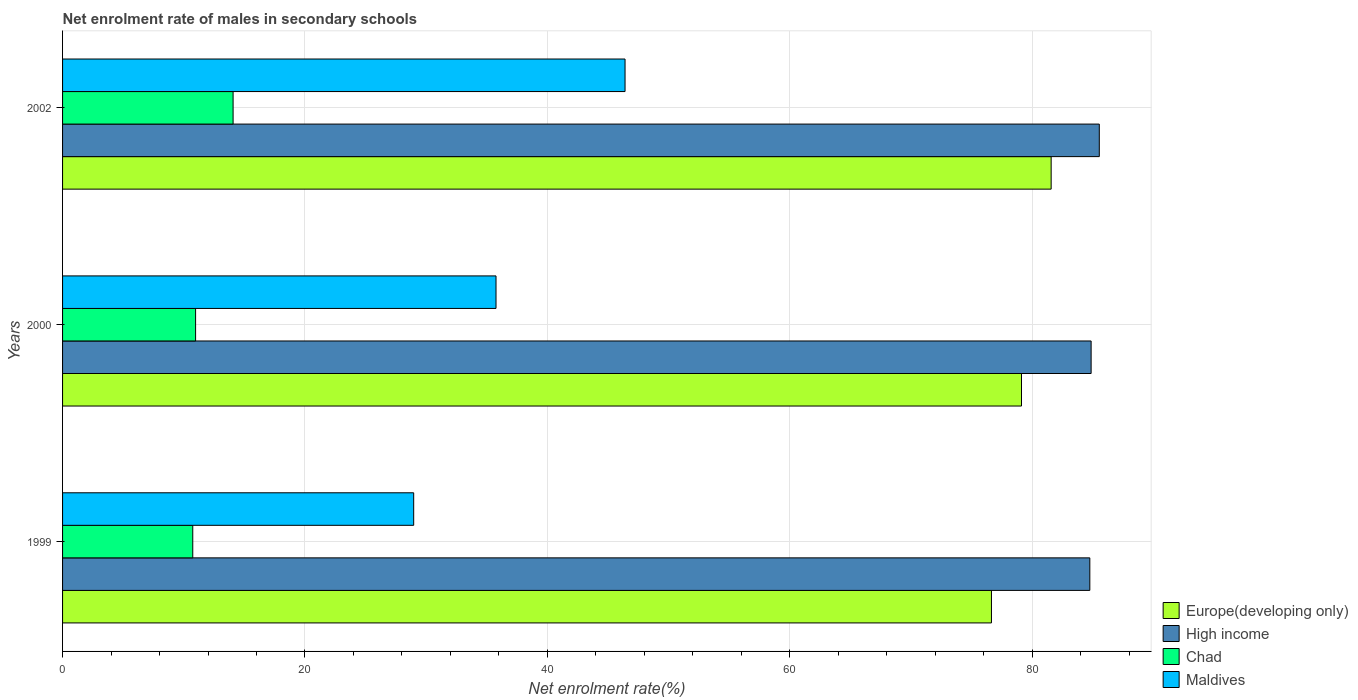How many different coloured bars are there?
Provide a succinct answer. 4. How many groups of bars are there?
Ensure brevity in your answer.  3. Are the number of bars per tick equal to the number of legend labels?
Ensure brevity in your answer.  Yes. Are the number of bars on each tick of the Y-axis equal?
Your response must be concise. Yes. How many bars are there on the 2nd tick from the bottom?
Your answer should be very brief. 4. What is the label of the 2nd group of bars from the top?
Your answer should be very brief. 2000. In how many cases, is the number of bars for a given year not equal to the number of legend labels?
Your answer should be compact. 0. What is the net enrolment rate of males in secondary schools in High income in 2002?
Your response must be concise. 85.54. Across all years, what is the maximum net enrolment rate of males in secondary schools in Europe(developing only)?
Provide a succinct answer. 81.56. Across all years, what is the minimum net enrolment rate of males in secondary schools in Chad?
Your answer should be compact. 10.74. What is the total net enrolment rate of males in secondary schools in Maldives in the graph?
Give a very brief answer. 111.14. What is the difference between the net enrolment rate of males in secondary schools in High income in 2000 and that in 2002?
Your answer should be compact. -0.67. What is the difference between the net enrolment rate of males in secondary schools in High income in 2000 and the net enrolment rate of males in secondary schools in Maldives in 1999?
Ensure brevity in your answer.  55.89. What is the average net enrolment rate of males in secondary schools in Maldives per year?
Make the answer very short. 37.05. In the year 1999, what is the difference between the net enrolment rate of males in secondary schools in High income and net enrolment rate of males in secondary schools in Europe(developing only)?
Give a very brief answer. 8.12. In how many years, is the net enrolment rate of males in secondary schools in Europe(developing only) greater than 28 %?
Keep it short and to the point. 3. What is the ratio of the net enrolment rate of males in secondary schools in High income in 1999 to that in 2000?
Your response must be concise. 1. Is the net enrolment rate of males in secondary schools in Chad in 2000 less than that in 2002?
Give a very brief answer. Yes. Is the difference between the net enrolment rate of males in secondary schools in High income in 1999 and 2000 greater than the difference between the net enrolment rate of males in secondary schools in Europe(developing only) in 1999 and 2000?
Provide a succinct answer. Yes. What is the difference between the highest and the second highest net enrolment rate of males in secondary schools in Chad?
Offer a very short reply. 3.09. What is the difference between the highest and the lowest net enrolment rate of males in secondary schools in Europe(developing only)?
Offer a terse response. 4.93. In how many years, is the net enrolment rate of males in secondary schools in Chad greater than the average net enrolment rate of males in secondary schools in Chad taken over all years?
Provide a short and direct response. 1. What does the 2nd bar from the top in 2002 represents?
Your response must be concise. Chad. What does the 3rd bar from the bottom in 1999 represents?
Your answer should be compact. Chad. Is it the case that in every year, the sum of the net enrolment rate of males in secondary schools in High income and net enrolment rate of males in secondary schools in Europe(developing only) is greater than the net enrolment rate of males in secondary schools in Maldives?
Offer a terse response. Yes. How many bars are there?
Your answer should be compact. 12. How many years are there in the graph?
Your answer should be compact. 3. What is the difference between two consecutive major ticks on the X-axis?
Offer a terse response. 20. Does the graph contain any zero values?
Keep it short and to the point. No. What is the title of the graph?
Offer a terse response. Net enrolment rate of males in secondary schools. What is the label or title of the X-axis?
Ensure brevity in your answer.  Net enrolment rate(%). What is the label or title of the Y-axis?
Give a very brief answer. Years. What is the Net enrolment rate(%) in Europe(developing only) in 1999?
Offer a terse response. 76.64. What is the Net enrolment rate(%) in High income in 1999?
Give a very brief answer. 84.75. What is the Net enrolment rate(%) of Chad in 1999?
Make the answer very short. 10.74. What is the Net enrolment rate(%) of Maldives in 1999?
Make the answer very short. 28.97. What is the Net enrolment rate(%) in Europe(developing only) in 2000?
Give a very brief answer. 79.12. What is the Net enrolment rate(%) in High income in 2000?
Make the answer very short. 84.86. What is the Net enrolment rate(%) of Chad in 2000?
Provide a short and direct response. 10.98. What is the Net enrolment rate(%) of Maldives in 2000?
Provide a short and direct response. 35.76. What is the Net enrolment rate(%) of Europe(developing only) in 2002?
Provide a short and direct response. 81.56. What is the Net enrolment rate(%) in High income in 2002?
Give a very brief answer. 85.54. What is the Net enrolment rate(%) of Chad in 2002?
Give a very brief answer. 14.07. What is the Net enrolment rate(%) of Maldives in 2002?
Your answer should be very brief. 46.41. Across all years, what is the maximum Net enrolment rate(%) of Europe(developing only)?
Make the answer very short. 81.56. Across all years, what is the maximum Net enrolment rate(%) in High income?
Provide a succinct answer. 85.54. Across all years, what is the maximum Net enrolment rate(%) of Chad?
Provide a succinct answer. 14.07. Across all years, what is the maximum Net enrolment rate(%) of Maldives?
Ensure brevity in your answer.  46.41. Across all years, what is the minimum Net enrolment rate(%) of Europe(developing only)?
Ensure brevity in your answer.  76.64. Across all years, what is the minimum Net enrolment rate(%) in High income?
Provide a succinct answer. 84.75. Across all years, what is the minimum Net enrolment rate(%) in Chad?
Provide a succinct answer. 10.74. Across all years, what is the minimum Net enrolment rate(%) in Maldives?
Your answer should be compact. 28.97. What is the total Net enrolment rate(%) in Europe(developing only) in the graph?
Provide a succinct answer. 237.32. What is the total Net enrolment rate(%) of High income in the graph?
Provide a succinct answer. 255.15. What is the total Net enrolment rate(%) in Chad in the graph?
Ensure brevity in your answer.  35.79. What is the total Net enrolment rate(%) in Maldives in the graph?
Offer a terse response. 111.14. What is the difference between the Net enrolment rate(%) in Europe(developing only) in 1999 and that in 2000?
Keep it short and to the point. -2.48. What is the difference between the Net enrolment rate(%) in High income in 1999 and that in 2000?
Keep it short and to the point. -0.11. What is the difference between the Net enrolment rate(%) of Chad in 1999 and that in 2000?
Provide a short and direct response. -0.23. What is the difference between the Net enrolment rate(%) in Maldives in 1999 and that in 2000?
Your answer should be very brief. -6.79. What is the difference between the Net enrolment rate(%) of Europe(developing only) in 1999 and that in 2002?
Give a very brief answer. -4.93. What is the difference between the Net enrolment rate(%) in High income in 1999 and that in 2002?
Offer a very short reply. -0.78. What is the difference between the Net enrolment rate(%) of Chad in 1999 and that in 2002?
Ensure brevity in your answer.  -3.33. What is the difference between the Net enrolment rate(%) of Maldives in 1999 and that in 2002?
Provide a succinct answer. -17.44. What is the difference between the Net enrolment rate(%) of Europe(developing only) in 2000 and that in 2002?
Your response must be concise. -2.45. What is the difference between the Net enrolment rate(%) in High income in 2000 and that in 2002?
Your answer should be very brief. -0.67. What is the difference between the Net enrolment rate(%) of Chad in 2000 and that in 2002?
Your response must be concise. -3.09. What is the difference between the Net enrolment rate(%) in Maldives in 2000 and that in 2002?
Offer a terse response. -10.65. What is the difference between the Net enrolment rate(%) in Europe(developing only) in 1999 and the Net enrolment rate(%) in High income in 2000?
Ensure brevity in your answer.  -8.22. What is the difference between the Net enrolment rate(%) of Europe(developing only) in 1999 and the Net enrolment rate(%) of Chad in 2000?
Make the answer very short. 65.66. What is the difference between the Net enrolment rate(%) in Europe(developing only) in 1999 and the Net enrolment rate(%) in Maldives in 2000?
Your answer should be very brief. 40.88. What is the difference between the Net enrolment rate(%) in High income in 1999 and the Net enrolment rate(%) in Chad in 2000?
Provide a succinct answer. 73.78. What is the difference between the Net enrolment rate(%) in High income in 1999 and the Net enrolment rate(%) in Maldives in 2000?
Make the answer very short. 48.99. What is the difference between the Net enrolment rate(%) of Chad in 1999 and the Net enrolment rate(%) of Maldives in 2000?
Give a very brief answer. -25.02. What is the difference between the Net enrolment rate(%) of Europe(developing only) in 1999 and the Net enrolment rate(%) of High income in 2002?
Offer a very short reply. -8.9. What is the difference between the Net enrolment rate(%) in Europe(developing only) in 1999 and the Net enrolment rate(%) in Chad in 2002?
Provide a succinct answer. 62.57. What is the difference between the Net enrolment rate(%) in Europe(developing only) in 1999 and the Net enrolment rate(%) in Maldives in 2002?
Give a very brief answer. 30.23. What is the difference between the Net enrolment rate(%) of High income in 1999 and the Net enrolment rate(%) of Chad in 2002?
Offer a very short reply. 70.69. What is the difference between the Net enrolment rate(%) in High income in 1999 and the Net enrolment rate(%) in Maldives in 2002?
Your answer should be very brief. 38.35. What is the difference between the Net enrolment rate(%) in Chad in 1999 and the Net enrolment rate(%) in Maldives in 2002?
Your answer should be very brief. -35.67. What is the difference between the Net enrolment rate(%) of Europe(developing only) in 2000 and the Net enrolment rate(%) of High income in 2002?
Make the answer very short. -6.42. What is the difference between the Net enrolment rate(%) in Europe(developing only) in 2000 and the Net enrolment rate(%) in Chad in 2002?
Ensure brevity in your answer.  65.05. What is the difference between the Net enrolment rate(%) of Europe(developing only) in 2000 and the Net enrolment rate(%) of Maldives in 2002?
Make the answer very short. 32.71. What is the difference between the Net enrolment rate(%) of High income in 2000 and the Net enrolment rate(%) of Chad in 2002?
Offer a very short reply. 70.79. What is the difference between the Net enrolment rate(%) in High income in 2000 and the Net enrolment rate(%) in Maldives in 2002?
Keep it short and to the point. 38.45. What is the difference between the Net enrolment rate(%) of Chad in 2000 and the Net enrolment rate(%) of Maldives in 2002?
Your answer should be very brief. -35.43. What is the average Net enrolment rate(%) of Europe(developing only) per year?
Keep it short and to the point. 79.11. What is the average Net enrolment rate(%) in High income per year?
Your answer should be very brief. 85.05. What is the average Net enrolment rate(%) in Chad per year?
Ensure brevity in your answer.  11.93. What is the average Net enrolment rate(%) of Maldives per year?
Your response must be concise. 37.05. In the year 1999, what is the difference between the Net enrolment rate(%) in Europe(developing only) and Net enrolment rate(%) in High income?
Offer a terse response. -8.12. In the year 1999, what is the difference between the Net enrolment rate(%) of Europe(developing only) and Net enrolment rate(%) of Chad?
Offer a terse response. 65.9. In the year 1999, what is the difference between the Net enrolment rate(%) in Europe(developing only) and Net enrolment rate(%) in Maldives?
Provide a short and direct response. 47.67. In the year 1999, what is the difference between the Net enrolment rate(%) in High income and Net enrolment rate(%) in Chad?
Give a very brief answer. 74.01. In the year 1999, what is the difference between the Net enrolment rate(%) in High income and Net enrolment rate(%) in Maldives?
Make the answer very short. 55.79. In the year 1999, what is the difference between the Net enrolment rate(%) in Chad and Net enrolment rate(%) in Maldives?
Provide a succinct answer. -18.23. In the year 2000, what is the difference between the Net enrolment rate(%) of Europe(developing only) and Net enrolment rate(%) of High income?
Provide a succinct answer. -5.74. In the year 2000, what is the difference between the Net enrolment rate(%) in Europe(developing only) and Net enrolment rate(%) in Chad?
Make the answer very short. 68.14. In the year 2000, what is the difference between the Net enrolment rate(%) in Europe(developing only) and Net enrolment rate(%) in Maldives?
Provide a short and direct response. 43.35. In the year 2000, what is the difference between the Net enrolment rate(%) in High income and Net enrolment rate(%) in Chad?
Give a very brief answer. 73.89. In the year 2000, what is the difference between the Net enrolment rate(%) of High income and Net enrolment rate(%) of Maldives?
Give a very brief answer. 49.1. In the year 2000, what is the difference between the Net enrolment rate(%) in Chad and Net enrolment rate(%) in Maldives?
Your answer should be compact. -24.79. In the year 2002, what is the difference between the Net enrolment rate(%) of Europe(developing only) and Net enrolment rate(%) of High income?
Offer a very short reply. -3.97. In the year 2002, what is the difference between the Net enrolment rate(%) in Europe(developing only) and Net enrolment rate(%) in Chad?
Make the answer very short. 67.49. In the year 2002, what is the difference between the Net enrolment rate(%) in Europe(developing only) and Net enrolment rate(%) in Maldives?
Your answer should be compact. 35.16. In the year 2002, what is the difference between the Net enrolment rate(%) in High income and Net enrolment rate(%) in Chad?
Your answer should be compact. 71.47. In the year 2002, what is the difference between the Net enrolment rate(%) of High income and Net enrolment rate(%) of Maldives?
Give a very brief answer. 39.13. In the year 2002, what is the difference between the Net enrolment rate(%) of Chad and Net enrolment rate(%) of Maldives?
Ensure brevity in your answer.  -32.34. What is the ratio of the Net enrolment rate(%) in Europe(developing only) in 1999 to that in 2000?
Make the answer very short. 0.97. What is the ratio of the Net enrolment rate(%) of High income in 1999 to that in 2000?
Your answer should be compact. 1. What is the ratio of the Net enrolment rate(%) in Chad in 1999 to that in 2000?
Provide a short and direct response. 0.98. What is the ratio of the Net enrolment rate(%) in Maldives in 1999 to that in 2000?
Give a very brief answer. 0.81. What is the ratio of the Net enrolment rate(%) in Europe(developing only) in 1999 to that in 2002?
Offer a terse response. 0.94. What is the ratio of the Net enrolment rate(%) in High income in 1999 to that in 2002?
Ensure brevity in your answer.  0.99. What is the ratio of the Net enrolment rate(%) in Chad in 1999 to that in 2002?
Keep it short and to the point. 0.76. What is the ratio of the Net enrolment rate(%) of Maldives in 1999 to that in 2002?
Offer a terse response. 0.62. What is the ratio of the Net enrolment rate(%) of Europe(developing only) in 2000 to that in 2002?
Give a very brief answer. 0.97. What is the ratio of the Net enrolment rate(%) in Chad in 2000 to that in 2002?
Offer a terse response. 0.78. What is the ratio of the Net enrolment rate(%) of Maldives in 2000 to that in 2002?
Your answer should be very brief. 0.77. What is the difference between the highest and the second highest Net enrolment rate(%) of Europe(developing only)?
Give a very brief answer. 2.45. What is the difference between the highest and the second highest Net enrolment rate(%) in High income?
Give a very brief answer. 0.67. What is the difference between the highest and the second highest Net enrolment rate(%) of Chad?
Provide a succinct answer. 3.09. What is the difference between the highest and the second highest Net enrolment rate(%) in Maldives?
Keep it short and to the point. 10.65. What is the difference between the highest and the lowest Net enrolment rate(%) in Europe(developing only)?
Offer a terse response. 4.93. What is the difference between the highest and the lowest Net enrolment rate(%) of High income?
Provide a succinct answer. 0.78. What is the difference between the highest and the lowest Net enrolment rate(%) of Chad?
Provide a succinct answer. 3.33. What is the difference between the highest and the lowest Net enrolment rate(%) of Maldives?
Offer a very short reply. 17.44. 